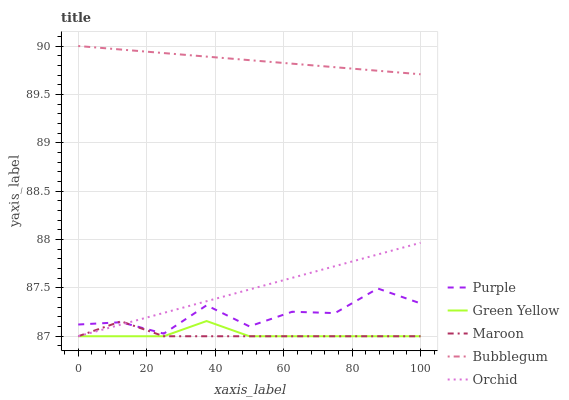Does Maroon have the minimum area under the curve?
Answer yes or no. Yes. Does Bubblegum have the maximum area under the curve?
Answer yes or no. Yes. Does Green Yellow have the minimum area under the curve?
Answer yes or no. No. Does Green Yellow have the maximum area under the curve?
Answer yes or no. No. Is Bubblegum the smoothest?
Answer yes or no. Yes. Is Purple the roughest?
Answer yes or no. Yes. Is Green Yellow the smoothest?
Answer yes or no. No. Is Green Yellow the roughest?
Answer yes or no. No. Does Green Yellow have the lowest value?
Answer yes or no. Yes. Does Bubblegum have the lowest value?
Answer yes or no. No. Does Bubblegum have the highest value?
Answer yes or no. Yes. Does Green Yellow have the highest value?
Answer yes or no. No. Is Green Yellow less than Bubblegum?
Answer yes or no. Yes. Is Purple greater than Green Yellow?
Answer yes or no. Yes. Does Green Yellow intersect Orchid?
Answer yes or no. Yes. Is Green Yellow less than Orchid?
Answer yes or no. No. Is Green Yellow greater than Orchid?
Answer yes or no. No. Does Green Yellow intersect Bubblegum?
Answer yes or no. No. 